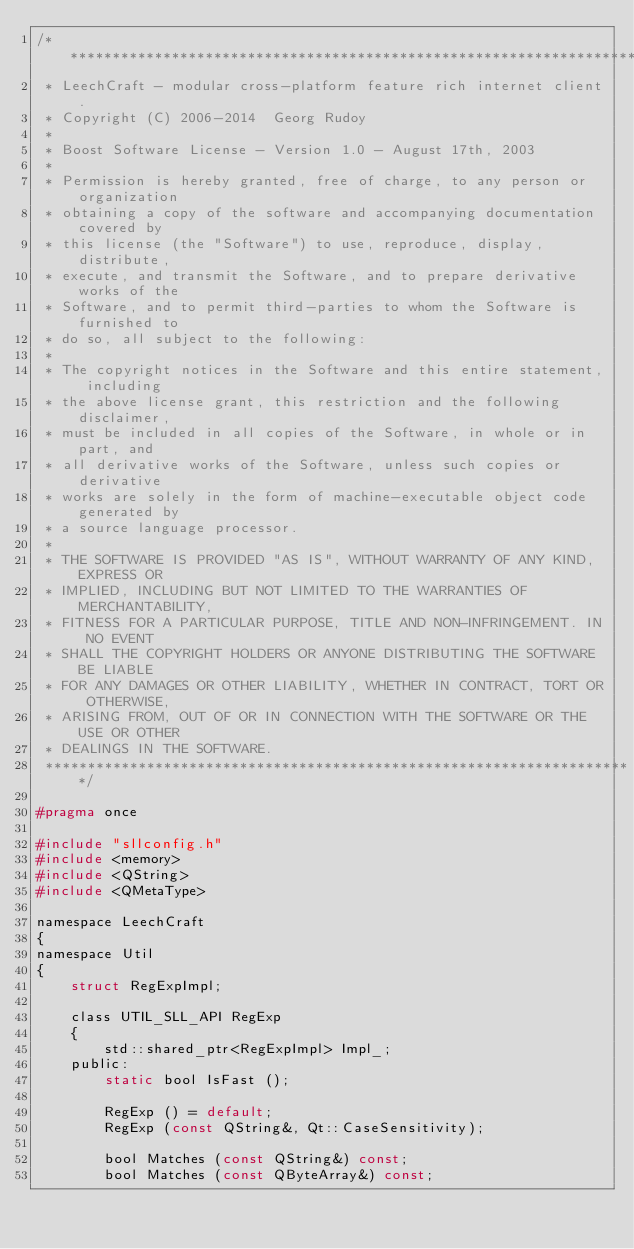<code> <loc_0><loc_0><loc_500><loc_500><_C_>/**********************************************************************
 * LeechCraft - modular cross-platform feature rich internet client.
 * Copyright (C) 2006-2014  Georg Rudoy
 *
 * Boost Software License - Version 1.0 - August 17th, 2003
 *
 * Permission is hereby granted, free of charge, to any person or organization
 * obtaining a copy of the software and accompanying documentation covered by
 * this license (the "Software") to use, reproduce, display, distribute,
 * execute, and transmit the Software, and to prepare derivative works of the
 * Software, and to permit third-parties to whom the Software is furnished to
 * do so, all subject to the following:
 *
 * The copyright notices in the Software and this entire statement, including
 * the above license grant, this restriction and the following disclaimer,
 * must be included in all copies of the Software, in whole or in part, and
 * all derivative works of the Software, unless such copies or derivative
 * works are solely in the form of machine-executable object code generated by
 * a source language processor.
 *
 * THE SOFTWARE IS PROVIDED "AS IS", WITHOUT WARRANTY OF ANY KIND, EXPRESS OR
 * IMPLIED, INCLUDING BUT NOT LIMITED TO THE WARRANTIES OF MERCHANTABILITY,
 * FITNESS FOR A PARTICULAR PURPOSE, TITLE AND NON-INFRINGEMENT. IN NO EVENT
 * SHALL THE COPYRIGHT HOLDERS OR ANYONE DISTRIBUTING THE SOFTWARE BE LIABLE
 * FOR ANY DAMAGES OR OTHER LIABILITY, WHETHER IN CONTRACT, TORT OR OTHERWISE,
 * ARISING FROM, OUT OF OR IN CONNECTION WITH THE SOFTWARE OR THE USE OR OTHER
 * DEALINGS IN THE SOFTWARE.
 **********************************************************************/

#pragma once

#include "sllconfig.h"
#include <memory>
#include <QString>
#include <QMetaType>

namespace LeechCraft
{
namespace Util
{
	struct RegExpImpl;

	class UTIL_SLL_API RegExp
	{
		std::shared_ptr<RegExpImpl> Impl_;
	public:
		static bool IsFast ();

		RegExp () = default;
		RegExp (const QString&, Qt::CaseSensitivity);

		bool Matches (const QString&) const;
		bool Matches (const QByteArray&) const;
</code> 